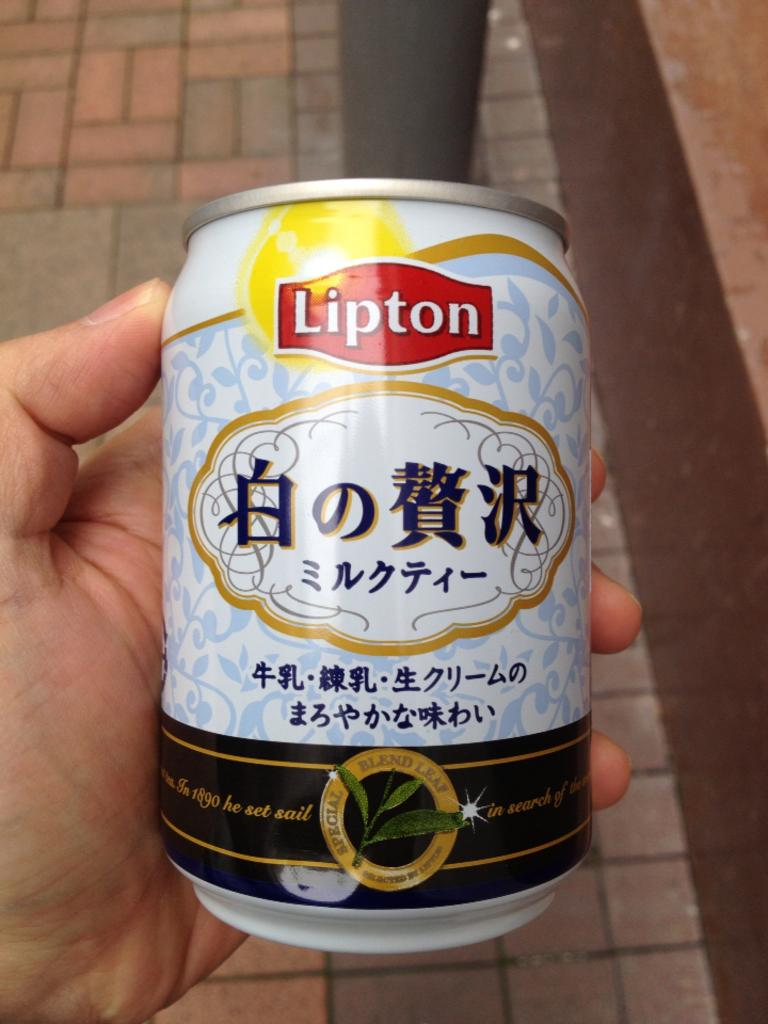What part of a person's body is visible in the image? There is a person's hand in the image. What is the person holding in the image? The person is holding a Lipton tin. What can be seen in the background of the image? There is a path visible in the background of the image. How many tails can be seen on the person in the image? There are no tails visible in the image, as the subject is a person's hand holding a Lipton tin. 